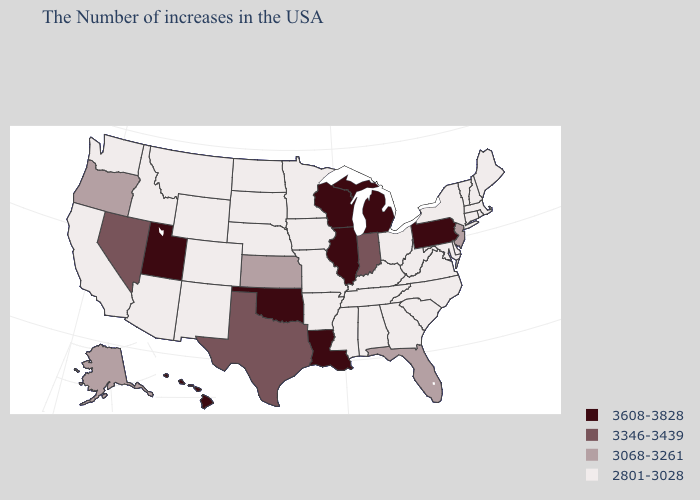Name the states that have a value in the range 3608-3828?
Be succinct. Pennsylvania, Michigan, Wisconsin, Illinois, Louisiana, Oklahoma, Utah, Hawaii. Among the states that border Utah , which have the lowest value?
Quick response, please. Wyoming, Colorado, New Mexico, Arizona, Idaho. What is the lowest value in the MidWest?
Keep it brief. 2801-3028. Name the states that have a value in the range 3346-3439?
Keep it brief. Indiana, Texas, Nevada. Name the states that have a value in the range 3068-3261?
Short answer required. New Jersey, Florida, Kansas, Oregon, Alaska. Does Louisiana have the lowest value in the South?
Be succinct. No. What is the value of Rhode Island?
Write a very short answer. 2801-3028. Name the states that have a value in the range 2801-3028?
Be succinct. Maine, Massachusetts, Rhode Island, New Hampshire, Vermont, Connecticut, New York, Delaware, Maryland, Virginia, North Carolina, South Carolina, West Virginia, Ohio, Georgia, Kentucky, Alabama, Tennessee, Mississippi, Missouri, Arkansas, Minnesota, Iowa, Nebraska, South Dakota, North Dakota, Wyoming, Colorado, New Mexico, Montana, Arizona, Idaho, California, Washington. What is the lowest value in the West?
Give a very brief answer. 2801-3028. What is the lowest value in the USA?
Short answer required. 2801-3028. Does New Jersey have the same value as Wyoming?
Write a very short answer. No. What is the value of Florida?
Give a very brief answer. 3068-3261. Name the states that have a value in the range 3608-3828?
Give a very brief answer. Pennsylvania, Michigan, Wisconsin, Illinois, Louisiana, Oklahoma, Utah, Hawaii. 